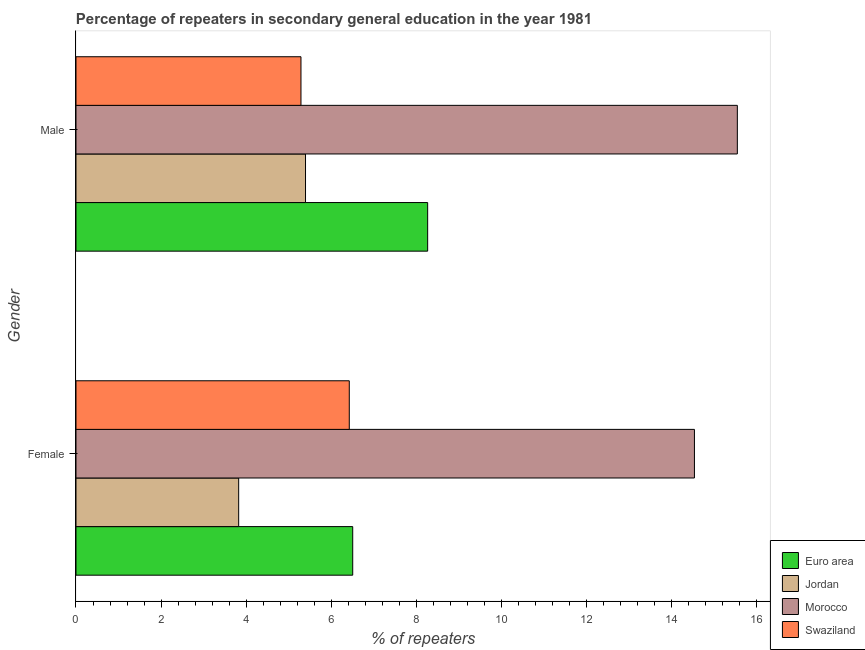Are the number of bars per tick equal to the number of legend labels?
Keep it short and to the point. Yes. Are the number of bars on each tick of the Y-axis equal?
Provide a succinct answer. Yes. How many bars are there on the 1st tick from the top?
Ensure brevity in your answer.  4. How many bars are there on the 2nd tick from the bottom?
Provide a short and direct response. 4. What is the label of the 2nd group of bars from the top?
Offer a very short reply. Female. What is the percentage of male repeaters in Jordan?
Provide a succinct answer. 5.4. Across all countries, what is the maximum percentage of female repeaters?
Provide a succinct answer. 14.54. Across all countries, what is the minimum percentage of male repeaters?
Your answer should be very brief. 5.29. In which country was the percentage of female repeaters maximum?
Provide a succinct answer. Morocco. In which country was the percentage of male repeaters minimum?
Make the answer very short. Swaziland. What is the total percentage of female repeaters in the graph?
Keep it short and to the point. 31.29. What is the difference between the percentage of female repeaters in Euro area and that in Swaziland?
Your answer should be compact. 0.08. What is the difference between the percentage of female repeaters in Jordan and the percentage of male repeaters in Morocco?
Offer a very short reply. -11.72. What is the average percentage of male repeaters per country?
Offer a terse response. 8.62. What is the difference between the percentage of male repeaters and percentage of female repeaters in Morocco?
Give a very brief answer. 1.01. In how many countries, is the percentage of male repeaters greater than 9.6 %?
Your response must be concise. 1. What is the ratio of the percentage of female repeaters in Jordan to that in Morocco?
Keep it short and to the point. 0.26. Is the percentage of male repeaters in Morocco less than that in Jordan?
Offer a very short reply. No. What does the 2nd bar from the top in Female represents?
Provide a succinct answer. Morocco. What does the 2nd bar from the bottom in Female represents?
Provide a short and direct response. Jordan. How many bars are there?
Ensure brevity in your answer.  8. How many countries are there in the graph?
Offer a terse response. 4. Are the values on the major ticks of X-axis written in scientific E-notation?
Ensure brevity in your answer.  No. Where does the legend appear in the graph?
Provide a short and direct response. Bottom right. How many legend labels are there?
Your response must be concise. 4. What is the title of the graph?
Provide a succinct answer. Percentage of repeaters in secondary general education in the year 1981. What is the label or title of the X-axis?
Provide a succinct answer. % of repeaters. What is the % of repeaters of Euro area in Female?
Provide a short and direct response. 6.51. What is the % of repeaters of Jordan in Female?
Provide a succinct answer. 3.82. What is the % of repeaters of Morocco in Female?
Your answer should be compact. 14.54. What is the % of repeaters in Swaziland in Female?
Provide a succinct answer. 6.42. What is the % of repeaters of Euro area in Male?
Your answer should be compact. 8.27. What is the % of repeaters of Jordan in Male?
Give a very brief answer. 5.4. What is the % of repeaters in Morocco in Male?
Ensure brevity in your answer.  15.55. What is the % of repeaters of Swaziland in Male?
Provide a short and direct response. 5.29. Across all Gender, what is the maximum % of repeaters of Euro area?
Offer a very short reply. 8.27. Across all Gender, what is the maximum % of repeaters in Jordan?
Provide a succinct answer. 5.4. Across all Gender, what is the maximum % of repeaters of Morocco?
Ensure brevity in your answer.  15.55. Across all Gender, what is the maximum % of repeaters in Swaziland?
Keep it short and to the point. 6.42. Across all Gender, what is the minimum % of repeaters in Euro area?
Offer a very short reply. 6.51. Across all Gender, what is the minimum % of repeaters in Jordan?
Offer a terse response. 3.82. Across all Gender, what is the minimum % of repeaters of Morocco?
Make the answer very short. 14.54. Across all Gender, what is the minimum % of repeaters of Swaziland?
Your answer should be very brief. 5.29. What is the total % of repeaters of Euro area in the graph?
Keep it short and to the point. 14.77. What is the total % of repeaters of Jordan in the graph?
Ensure brevity in your answer.  9.22. What is the total % of repeaters in Morocco in the graph?
Give a very brief answer. 30.09. What is the total % of repeaters of Swaziland in the graph?
Your response must be concise. 11.71. What is the difference between the % of repeaters of Euro area in Female and that in Male?
Your response must be concise. -1.76. What is the difference between the % of repeaters in Jordan in Female and that in Male?
Your answer should be very brief. -1.57. What is the difference between the % of repeaters in Morocco in Female and that in Male?
Keep it short and to the point. -1.01. What is the difference between the % of repeaters of Swaziland in Female and that in Male?
Your answer should be very brief. 1.14. What is the difference between the % of repeaters in Euro area in Female and the % of repeaters in Jordan in Male?
Provide a short and direct response. 1.11. What is the difference between the % of repeaters in Euro area in Female and the % of repeaters in Morocco in Male?
Offer a very short reply. -9.04. What is the difference between the % of repeaters of Euro area in Female and the % of repeaters of Swaziland in Male?
Your response must be concise. 1.22. What is the difference between the % of repeaters of Jordan in Female and the % of repeaters of Morocco in Male?
Offer a very short reply. -11.72. What is the difference between the % of repeaters in Jordan in Female and the % of repeaters in Swaziland in Male?
Ensure brevity in your answer.  -1.46. What is the difference between the % of repeaters in Morocco in Female and the % of repeaters in Swaziland in Male?
Offer a very short reply. 9.25. What is the average % of repeaters of Euro area per Gender?
Provide a succinct answer. 7.39. What is the average % of repeaters of Jordan per Gender?
Provide a succinct answer. 4.61. What is the average % of repeaters of Morocco per Gender?
Your response must be concise. 15.04. What is the average % of repeaters in Swaziland per Gender?
Keep it short and to the point. 5.86. What is the difference between the % of repeaters of Euro area and % of repeaters of Jordan in Female?
Keep it short and to the point. 2.68. What is the difference between the % of repeaters of Euro area and % of repeaters of Morocco in Female?
Give a very brief answer. -8.03. What is the difference between the % of repeaters of Euro area and % of repeaters of Swaziland in Female?
Keep it short and to the point. 0.08. What is the difference between the % of repeaters of Jordan and % of repeaters of Morocco in Female?
Give a very brief answer. -10.71. What is the difference between the % of repeaters of Morocco and % of repeaters of Swaziland in Female?
Keep it short and to the point. 8.11. What is the difference between the % of repeaters of Euro area and % of repeaters of Jordan in Male?
Make the answer very short. 2.87. What is the difference between the % of repeaters in Euro area and % of repeaters in Morocco in Male?
Provide a short and direct response. -7.28. What is the difference between the % of repeaters in Euro area and % of repeaters in Swaziland in Male?
Keep it short and to the point. 2.98. What is the difference between the % of repeaters in Jordan and % of repeaters in Morocco in Male?
Your response must be concise. -10.15. What is the difference between the % of repeaters in Jordan and % of repeaters in Swaziland in Male?
Keep it short and to the point. 0.11. What is the difference between the % of repeaters of Morocco and % of repeaters of Swaziland in Male?
Your answer should be very brief. 10.26. What is the ratio of the % of repeaters of Euro area in Female to that in Male?
Keep it short and to the point. 0.79. What is the ratio of the % of repeaters in Jordan in Female to that in Male?
Your response must be concise. 0.71. What is the ratio of the % of repeaters of Morocco in Female to that in Male?
Offer a terse response. 0.94. What is the ratio of the % of repeaters of Swaziland in Female to that in Male?
Offer a terse response. 1.21. What is the difference between the highest and the second highest % of repeaters in Euro area?
Keep it short and to the point. 1.76. What is the difference between the highest and the second highest % of repeaters in Jordan?
Provide a short and direct response. 1.57. What is the difference between the highest and the second highest % of repeaters in Morocco?
Your answer should be compact. 1.01. What is the difference between the highest and the second highest % of repeaters in Swaziland?
Offer a very short reply. 1.14. What is the difference between the highest and the lowest % of repeaters in Euro area?
Your response must be concise. 1.76. What is the difference between the highest and the lowest % of repeaters in Jordan?
Offer a terse response. 1.57. What is the difference between the highest and the lowest % of repeaters in Morocco?
Provide a short and direct response. 1.01. What is the difference between the highest and the lowest % of repeaters in Swaziland?
Your answer should be very brief. 1.14. 